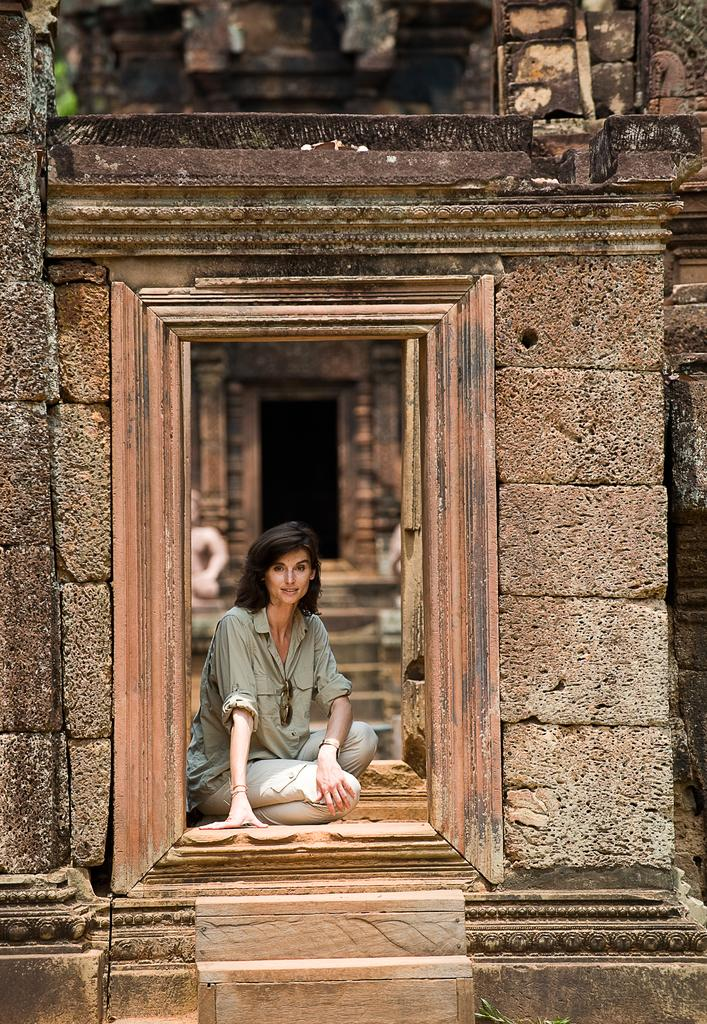What is the woman doing in the image? The woman is sitting in the image. Where is the woman located in relation to the door? The woman is in front of a door. What is visible behind the woman in the image? There is a wall at the back side of the image. How many stairs are present at the front of the image? There are two stairs at the front of the image. What type of wren can be seen perched on the door in the image? There is no wren present in the image; it only features a woman sitting in front of a door. 